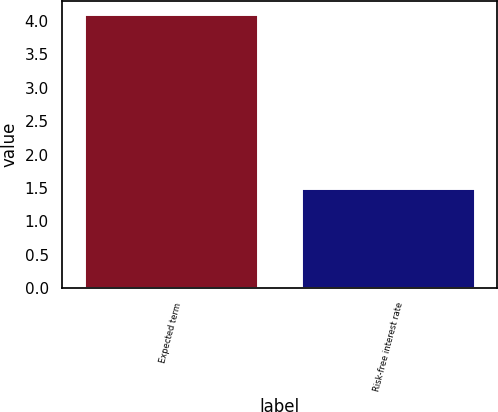<chart> <loc_0><loc_0><loc_500><loc_500><bar_chart><fcel>Expected term<fcel>Risk-free interest rate<nl><fcel>4.1<fcel>1.5<nl></chart> 